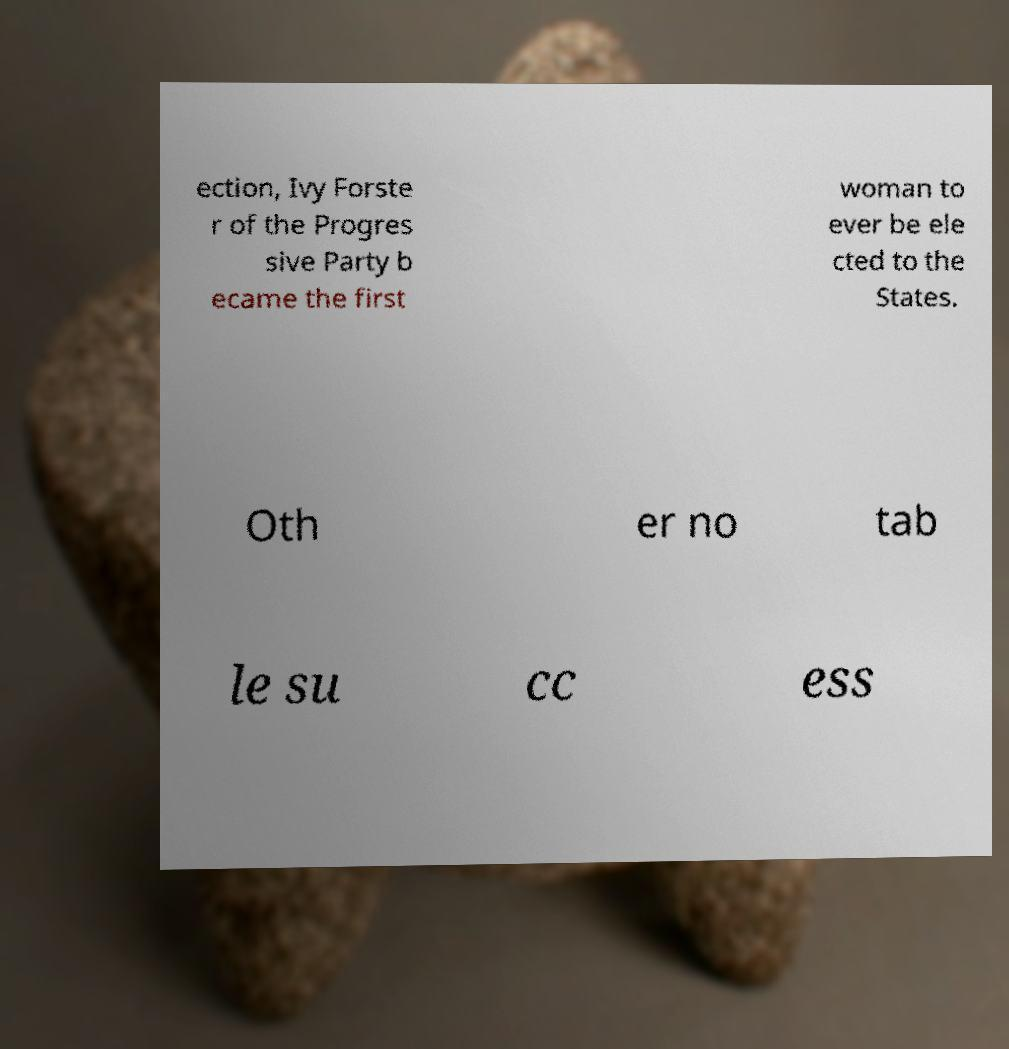Please identify and transcribe the text found in this image. ection, Ivy Forste r of the Progres sive Party b ecame the first woman to ever be ele cted to the States. Oth er no tab le su cc ess 